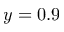Convert formula to latex. <formula><loc_0><loc_0><loc_500><loc_500>y = 0 . 9</formula> 